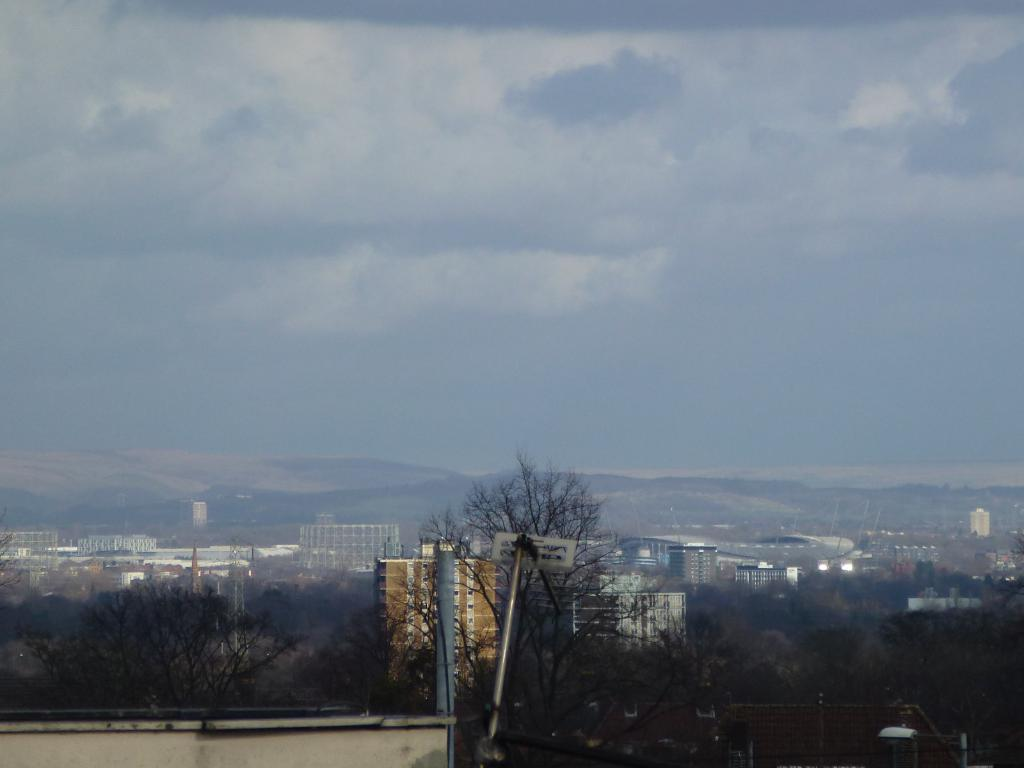What is the weather like in the image? The sky in the image is cloudy. What type of natural landscape can be seen in the image? There are mountains visible in the image. What type of vegetation is present at the bottom of the image? There are many trees at the bottom of the image. What type of man-made structures are visible in the image? There are buildings in the image. What type of vertical structures are present in the image? Poles are present in the image. Can you hear the bed creaking in the image? There is no bed present in the image, so it is not possible to hear any creaking. 